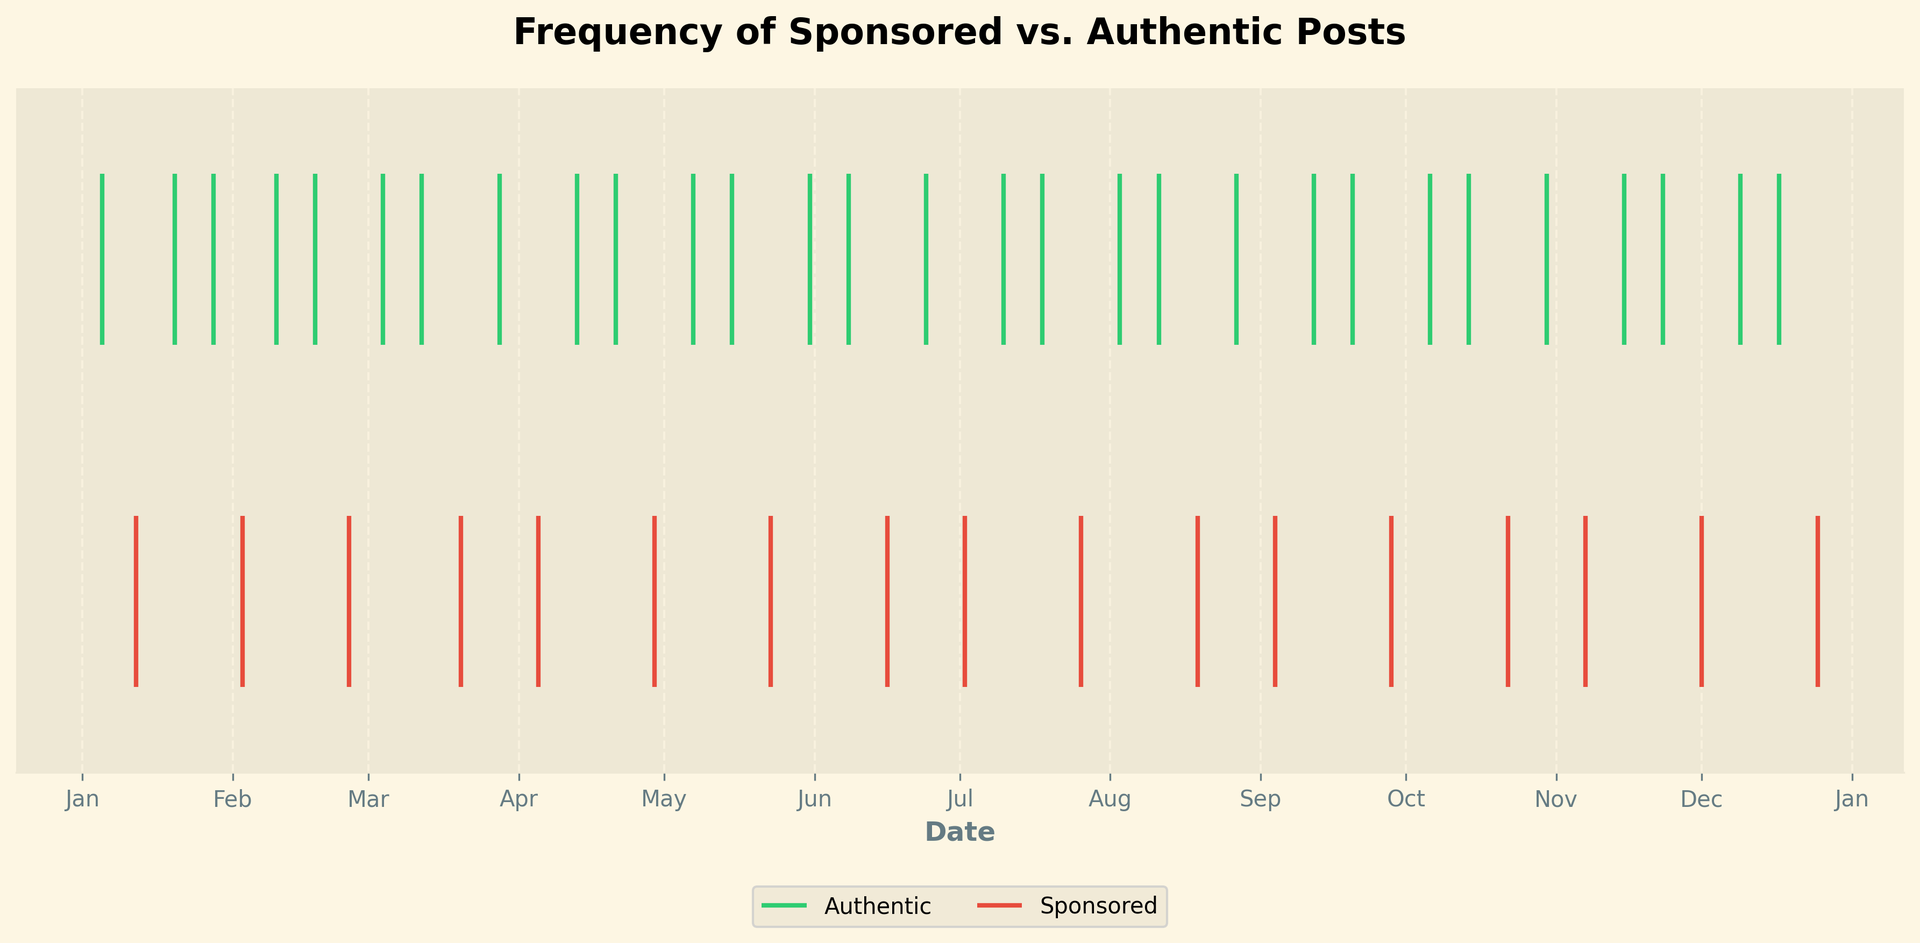What is the total number of authentic posts throughout the year? Count the number of green lines (each representing an authentic post) on the plot.
Answer: 26 Which month has the most sponsored posts? Check for the month with the highest concentration of red lines (each representing a sponsored post).
Answer: December On average, how many authentic posts are there per month? Divide the total number of authentic posts (26) by 12 months.
Answer: 2.17 Are there any months with only sponsored posts? Look for any month where only red lines appear without any green lines.
Answer: No Which quarter of the year has the highest frequency of authentic posts? Split the year into four quarters (Q1: Jan-Mar, Q2: Apr-Jun, Q3: Jul-Sep, Q4: Oct-Dec) and count the green lines in each quarter.
Answer: Q3 How does the frequency of sponsored posts change over the year? Observe if the red lines are more concentrated towards the beginning, middle, or end of the year.
Answer: Increases towards the end Is there any pattern in the posting of sponsored content? Observe if there is a periodic trend in the placement of red lines, such as occurring once a month.
Answer: Approximately once every month Which color represents authentic posts? Identify the color of the lines that represent authentic posts by looking at the legend.
Answer: Green What is the ratio of authentic posts to sponsored posts? Compare the total number of green lines (26) to the total number of red lines (12).
Answer: 26:12 or 13:6 In which month does the largest gap between authentic and sponsored posts occur? Identify the month with the most substantial difference in the count of green and red lines.
Answer: January 